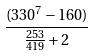Convert formula to latex. <formula><loc_0><loc_0><loc_500><loc_500>\frac { ( 3 3 0 ^ { 7 } - 1 6 0 ) } { \frac { 2 5 3 } { 4 1 9 } + 2 }</formula> 